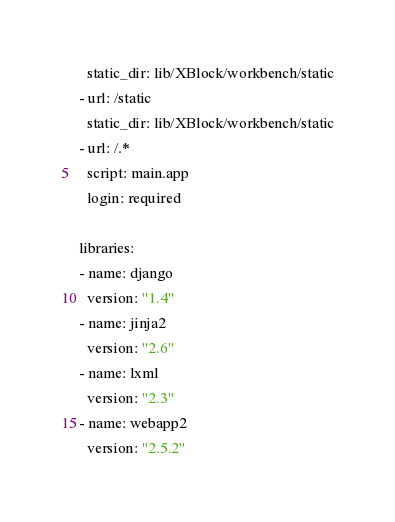<code> <loc_0><loc_0><loc_500><loc_500><_YAML_>  static_dir: lib/XBlock/workbench/static
- url: /static
  static_dir: lib/XBlock/workbench/static
- url: /.*
  script: main.app
  login: required

libraries:
- name: django
  version: "1.4"
- name: jinja2
  version: "2.6"
- name: lxml
  version: "2.3"
- name: webapp2
  version: "2.5.2"</code> 